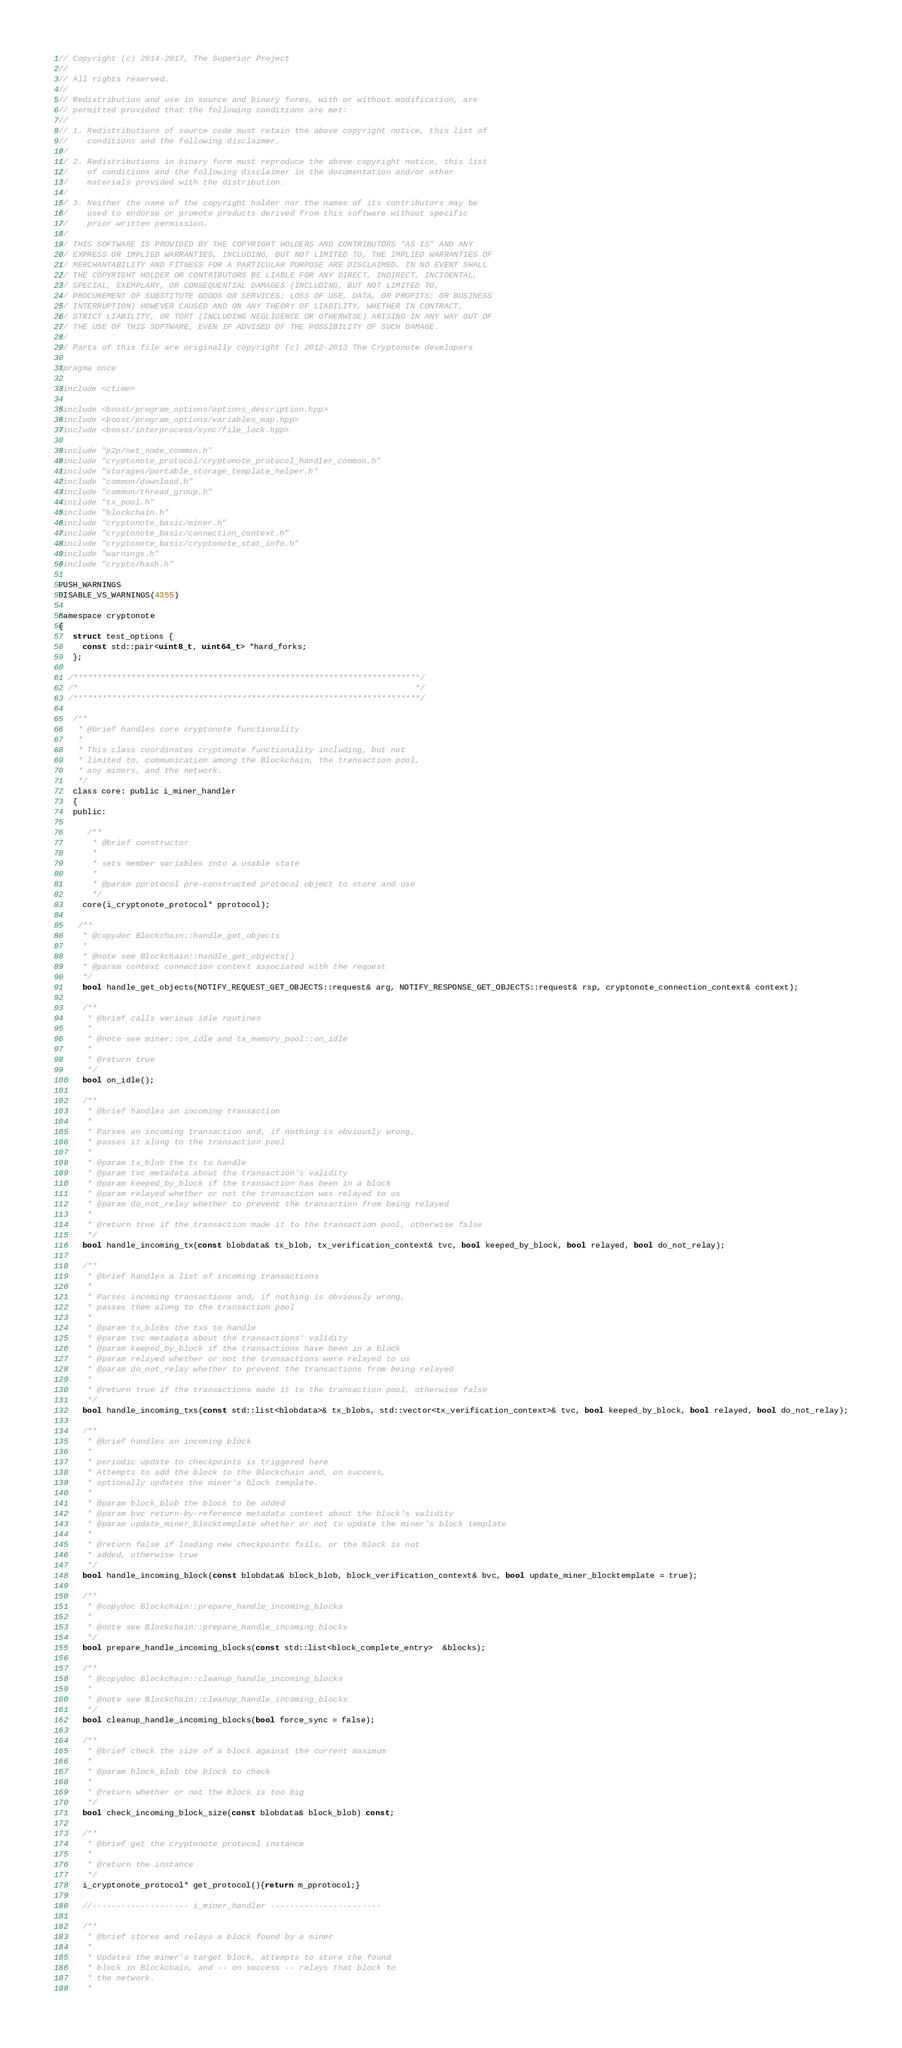<code> <loc_0><loc_0><loc_500><loc_500><_C_>// Copyright (c) 2014-2017, The Superior Project
//
// All rights reserved.
//
// Redistribution and use in source and binary forms, with or without modification, are
// permitted provided that the following conditions are met:
//
// 1. Redistributions of source code must retain the above copyright notice, this list of
//    conditions and the following disclaimer.
//
// 2. Redistributions in binary form must reproduce the above copyright notice, this list
//    of conditions and the following disclaimer in the documentation and/or other
//    materials provided with the distribution.
//
// 3. Neither the name of the copyright holder nor the names of its contributors may be
//    used to endorse or promote products derived from this software without specific
//    prior written permission.
//
// THIS SOFTWARE IS PROVIDED BY THE COPYRIGHT HOLDERS AND CONTRIBUTORS "AS IS" AND ANY
// EXPRESS OR IMPLIED WARRANTIES, INCLUDING, BUT NOT LIMITED TO, THE IMPLIED WARRANTIES OF
// MERCHANTABILITY AND FITNESS FOR A PARTICULAR PURPOSE ARE DISCLAIMED. IN NO EVENT SHALL
// THE COPYRIGHT HOLDER OR CONTRIBUTORS BE LIABLE FOR ANY DIRECT, INDIRECT, INCIDENTAL,
// SPECIAL, EXEMPLARY, OR CONSEQUENTIAL DAMAGES (INCLUDING, BUT NOT LIMITED TO,
// PROCUREMENT OF SUBSTITUTE GOODS OR SERVICES; LOSS OF USE, DATA, OR PROFITS; OR BUSINESS
// INTERRUPTION) HOWEVER CAUSED AND ON ANY THEORY OF LIABILITY, WHETHER IN CONTRACT,
// STRICT LIABILITY, OR TORT (INCLUDING NEGLIGENCE OR OTHERWISE) ARISING IN ANY WAY OUT OF
// THE USE OF THIS SOFTWARE, EVEN IF ADVISED OF THE POSSIBILITY OF SUCH DAMAGE.
//
// Parts of this file are originally copyright (c) 2012-2013 The Cryptonote developers

#pragma once

#include <ctime>

#include <boost/program_options/options_description.hpp>
#include <boost/program_options/variables_map.hpp>
#include <boost/interprocess/sync/file_lock.hpp>

#include "p2p/net_node_common.h"
#include "cryptonote_protocol/cryptonote_protocol_handler_common.h"
#include "storages/portable_storage_template_helper.h"
#include "common/download.h"
#include "common/thread_group.h"
#include "tx_pool.h"
#include "blockchain.h"
#include "cryptonote_basic/miner.h"
#include "cryptonote_basic/connection_context.h"
#include "cryptonote_basic/cryptonote_stat_info.h"
#include "warnings.h"
#include "crypto/hash.h"

PUSH_WARNINGS
DISABLE_VS_WARNINGS(4355)

namespace cryptonote
{
   struct test_options {
     const std::pair<uint8_t, uint64_t> *hard_forks;
   };

  /************************************************************************/
  /*                                                                      */
  /************************************************************************/

   /**
    * @brief handles core cryptonote functionality
    *
    * This class coordinates cryptonote functionality including, but not
    * limited to, communication among the Blockchain, the transaction pool,
    * any miners, and the network.
    */
   class core: public i_miner_handler
   {
   public:

      /**
       * @brief constructor
       *
       * sets member variables into a usable state
       *
       * @param pprotocol pre-constructed protocol object to store and use
       */
     core(i_cryptonote_protocol* pprotocol);

    /**
     * @copydoc Blockchain::handle_get_objects
     *
     * @note see Blockchain::handle_get_objects()
     * @param context connection context associated with the request
     */
     bool handle_get_objects(NOTIFY_REQUEST_GET_OBJECTS::request& arg, NOTIFY_RESPONSE_GET_OBJECTS::request& rsp, cryptonote_connection_context& context);

     /**
      * @brief calls various idle routines
      *
      * @note see miner::on_idle and tx_memory_pool::on_idle
      *
      * @return true
      */
     bool on_idle();

     /**
      * @brief handles an incoming transaction
      *
      * Parses an incoming transaction and, if nothing is obviously wrong,
      * passes it along to the transaction pool
      *
      * @param tx_blob the tx to handle
      * @param tvc metadata about the transaction's validity
      * @param keeped_by_block if the transaction has been in a block
      * @param relayed whether or not the transaction was relayed to us
      * @param do_not_relay whether to prevent the transaction from being relayed
      *
      * @return true if the transaction made it to the transaction pool, otherwise false
      */
     bool handle_incoming_tx(const blobdata& tx_blob, tx_verification_context& tvc, bool keeped_by_block, bool relayed, bool do_not_relay);

     /**
      * @brief handles a list of incoming transactions
      *
      * Parses incoming transactions and, if nothing is obviously wrong,
      * passes them along to the transaction pool
      *
      * @param tx_blobs the txs to handle
      * @param tvc metadata about the transactions' validity
      * @param keeped_by_block if the transactions have been in a block
      * @param relayed whether or not the transactions were relayed to us
      * @param do_not_relay whether to prevent the transactions from being relayed
      *
      * @return true if the transactions made it to the transaction pool, otherwise false
      */
     bool handle_incoming_txs(const std::list<blobdata>& tx_blobs, std::vector<tx_verification_context>& tvc, bool keeped_by_block, bool relayed, bool do_not_relay);

     /**
      * @brief handles an incoming block
      *
      * periodic update to checkpoints is triggered here
      * Attempts to add the block to the Blockchain and, on success,
      * optionally updates the miner's block template.
      *
      * @param block_blob the block to be added
      * @param bvc return-by-reference metadata context about the block's validity
      * @param update_miner_blocktemplate whether or not to update the miner's block template
      *
      * @return false if loading new checkpoints fails, or the block is not
      * added, otherwise true
      */
     bool handle_incoming_block(const blobdata& block_blob, block_verification_context& bvc, bool update_miner_blocktemplate = true);

     /**
      * @copydoc Blockchain::prepare_handle_incoming_blocks
      *
      * @note see Blockchain::prepare_handle_incoming_blocks
      */
     bool prepare_handle_incoming_blocks(const std::list<block_complete_entry>  &blocks);

     /**
      * @copydoc Blockchain::cleanup_handle_incoming_blocks
      *
      * @note see Blockchain::cleanup_handle_incoming_blocks
      */
     bool cleanup_handle_incoming_blocks(bool force_sync = false);
     	     	
     /**
      * @brief check the size of a block against the current maximum
      *
      * @param block_blob the block to check
      *
      * @return whether or not the block is too big
      */
     bool check_incoming_block_size(const blobdata& block_blob) const;

     /**
      * @brief get the cryptonote protocol instance
      *
      * @return the instance
      */
     i_cryptonote_protocol* get_protocol(){return m_pprotocol;}

     //-------------------- i_miner_handler -----------------------

     /**
      * @brief stores and relays a block found by a miner
      *
      * Updates the miner's target block, attempts to store the found
      * block in Blockchain, and -- on success -- relays that block to
      * the network.
      *</code> 